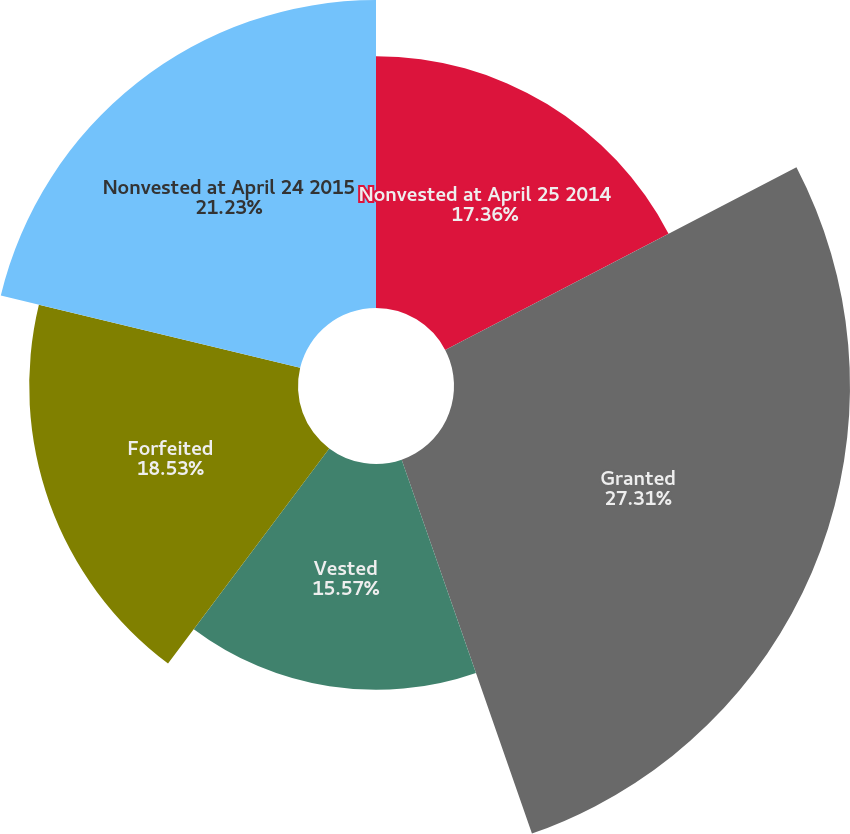Convert chart. <chart><loc_0><loc_0><loc_500><loc_500><pie_chart><fcel>Nonvested at April 25 2014<fcel>Granted<fcel>Vested<fcel>Forfeited<fcel>Nonvested at April 24 2015<nl><fcel>17.36%<fcel>27.3%<fcel>15.57%<fcel>18.53%<fcel>21.23%<nl></chart> 